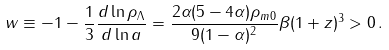Convert formula to latex. <formula><loc_0><loc_0><loc_500><loc_500>w \equiv - 1 - \frac { 1 } { 3 } \frac { d \ln \rho _ { \Lambda } } { d \ln a } = \frac { 2 \alpha ( 5 - 4 \alpha ) \rho _ { m 0 } } { 9 ( 1 - \alpha ) ^ { 2 } } \beta ( 1 + z ) ^ { 3 } > 0 \, .</formula> 